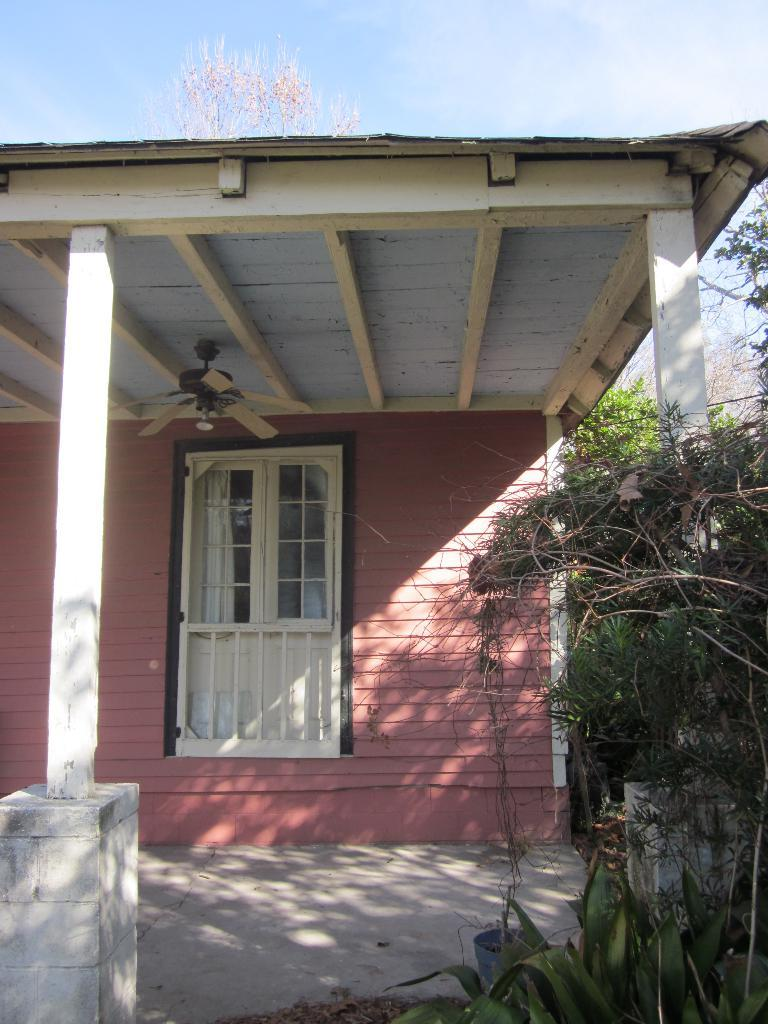What type of structure is visible in the image? There is a house in the image. What feature of the house is mentioned in the facts? The house has a window. Is there any additional detail about the house? Yes, there is a fan at the top of the house. What can be seen in the background of the image? There are trees and the sky visible in the background of the image. What type of hook can be seen hanging from the window in the image? There is no hook mentioned or visible in the image; the facts only mention a window and a fan at the top of the house. 